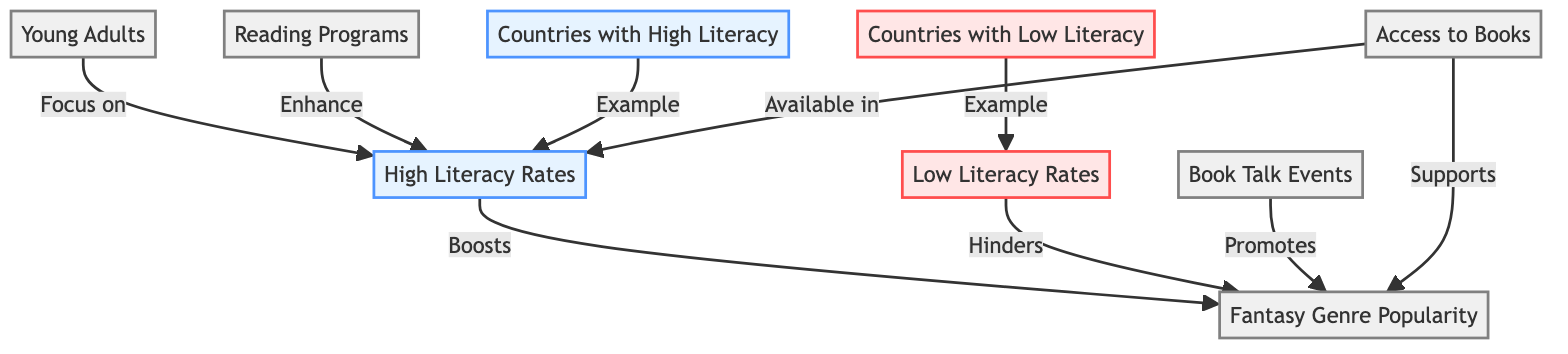What's a characteristic of countries with high literacy rates? According to the diagram, countries with high literacy rates are associated with young adults focusing on reading, indicating a positive environment for literacy.
Answer: High Literacy Rates What does low literacy rate hinder? The diagram shows that low literacy rates hinder the popularity of the fantasy genre, suggesting that a lack of literacy negatively impacts engagement with this genre.
Answer: Fantasy Genre Popularity How does a reading program influence literacy rates? The diagram indicates that reading programs enhance high literacy rates, which implies that these programs contribute positively to literacy levels among young adults.
Answer: Enhance What is necessary to boost fantasy genre popularity? The diagram indicates that high literacy rates boost the popularity of the fantasy genre, which means that increasing literacy is crucial for promoting this literary category.
Answer: High Literacy Rates Which element promotes fantasy genre popularity? The diagram connects book talk events as a component that promotes the popularity of the fantasy genre, highlighting their role in encouraging reading.
Answer: Promotes What kind of countries are examples for low literacy rates? The diagram designates countries with low literacy rates as examples that lead to challenges in engaging with the fantasy genre, showcasing the negative outcomes of low literacy.
Answer: Countries with Low Literacy How many nodes are in the diagram relating to reading programs? By counting the nodes within the diagram, there are a total of one specific node related directly to reading programs, which is explicitly noted.
Answer: 1 What is associated with higher access to books? The diagram indicates that higher access to books is associated with countries having high literacy rates, showing a clear link between availability of books and literacy.
Answer: High Literacy Rates What links reading programs and young adults? The diagram shows that reading programs focus on young adults, which symbolizes the targeted approach of such initiatives towards this demographic.
Answer: Focus on 